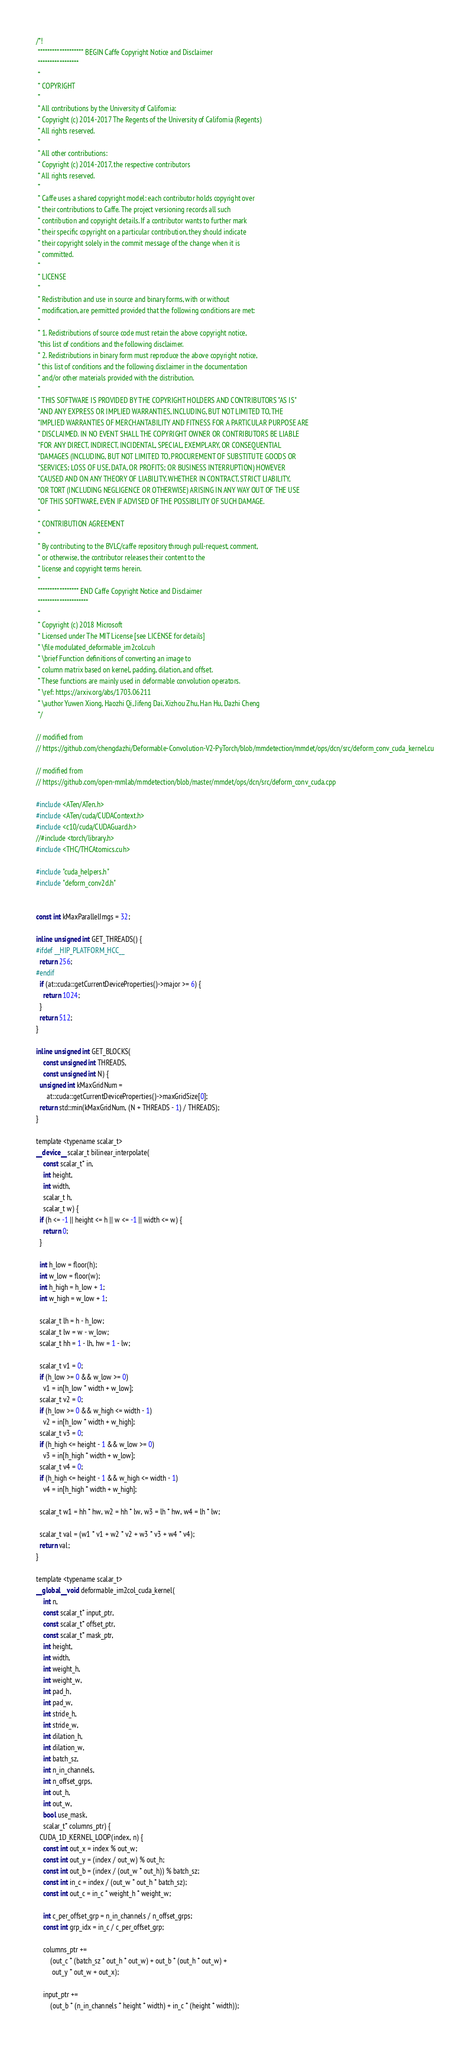<code> <loc_0><loc_0><loc_500><loc_500><_Cuda_>/*!
 ******************* BEGIN Caffe Copyright Notice and Disclaimer
 *****************
 *
 * COPYRIGHT
 *
 * All contributions by the University of California:
 * Copyright (c) 2014-2017 The Regents of the University of California (Regents)
 * All rights reserved.
 *
 * All other contributions:
 * Copyright (c) 2014-2017, the respective contributors
 * All rights reserved.
 *
 * Caffe uses a shared copyright model: each contributor holds copyright over
 * their contributions to Caffe. The project versioning records all such
 * contribution and copyright details. If a contributor wants to further mark
 * their specific copyright on a particular contribution, they should indicate
 * their copyright solely in the commit message of the change when it is
 * committed.
 *
 * LICENSE
 *
 * Redistribution and use in source and binary forms, with or without
 * modification, are permitted provided that the following conditions are met:
 *
 * 1. Redistributions of source code must retain the above copyright notice,
 *this list of conditions and the following disclaimer.
 * 2. Redistributions in binary form must reproduce the above copyright notice,
 * this list of conditions and the following disclaimer in the documentation
 * and/or other materials provided with the distribution.
 *
 * THIS SOFTWARE IS PROVIDED BY THE COPYRIGHT HOLDERS AND CONTRIBUTORS "AS IS"
 *AND ANY EXPRESS OR IMPLIED WARRANTIES, INCLUDING, BUT NOT LIMITED TO, THE
 *IMPLIED WARRANTIES OF MERCHANTABILITY AND FITNESS FOR A PARTICULAR PURPOSE ARE
 * DISCLAIMED. IN NO EVENT SHALL THE COPYRIGHT OWNER OR CONTRIBUTORS BE LIABLE
 *FOR ANY DIRECT, INDIRECT, INCIDENTAL, SPECIAL, EXEMPLARY, OR CONSEQUENTIAL
 *DAMAGES (INCLUDING, BUT NOT LIMITED TO, PROCUREMENT OF SUBSTITUTE GOODS OR
 *SERVICES; LOSS OF USE, DATA, OR PROFITS; OR BUSINESS INTERRUPTION) HOWEVER
 *CAUSED AND ON ANY THEORY OF LIABILITY, WHETHER IN CONTRACT, STRICT LIABILITY,
 *OR TORT (INCLUDING NEGLIGENCE OR OTHERWISE) ARISING IN ANY WAY OUT OF THE USE
 *OF THIS SOFTWARE, EVEN IF ADVISED OF THE POSSIBILITY OF SUCH DAMAGE.
 *
 * CONTRIBUTION AGREEMENT
 *
 * By contributing to the BVLC/caffe repository through pull-request, comment,
 * or otherwise, the contributor releases their content to the
 * license and copyright terms herein.
 *
 ***************** END Caffe Copyright Notice and Disclaimer
 *********************
 *
 * Copyright (c) 2018 Microsoft
 * Licensed under The MIT License [see LICENSE for details]
 * \file modulated_deformable_im2col.cuh
 * \brief Function definitions of converting an image to
 * column matrix based on kernel, padding, dilation, and offset.
 * These functions are mainly used in deformable convolution operators.
 * \ref: https://arxiv.org/abs/1703.06211
 * \author Yuwen Xiong, Haozhi Qi, Jifeng Dai, Xizhou Zhu, Han Hu, Dazhi Cheng
 */

// modified from
// https://github.com/chengdazhi/Deformable-Convolution-V2-PyTorch/blob/mmdetection/mmdet/ops/dcn/src/deform_conv_cuda_kernel.cu

// modified from
// https://github.com/open-mmlab/mmdetection/blob/master/mmdet/ops/dcn/src/deform_conv_cuda.cpp

#include <ATen/ATen.h>
#include <ATen/cuda/CUDAContext.h>
#include <c10/cuda/CUDAGuard.h>
//#include <torch/library.h>
#include <THC/THCAtomics.cuh>

#include "cuda_helpers.h"
#include "deform_conv2d.h"


const int kMaxParallelImgs = 32;

inline unsigned int GET_THREADS() {
#ifdef __HIP_PLATFORM_HCC__
  return 256;
#endif
  if (at::cuda::getCurrentDeviceProperties()->major >= 6) {
    return 1024;
  }
  return 512;
}

inline unsigned int GET_BLOCKS(
    const unsigned int THREADS,
    const unsigned int N) {
  unsigned int kMaxGridNum =
      at::cuda::getCurrentDeviceProperties()->maxGridSize[0];
  return std::min(kMaxGridNum, (N + THREADS - 1) / THREADS);
}

template <typename scalar_t>
__device__ scalar_t bilinear_interpolate(
    const scalar_t* in,
    int height,
    int width,
    scalar_t h,
    scalar_t w) {
  if (h <= -1 || height <= h || w <= -1 || width <= w) {
    return 0;
  }

  int h_low = floor(h);
  int w_low = floor(w);
  int h_high = h_low + 1;
  int w_high = w_low + 1;

  scalar_t lh = h - h_low;
  scalar_t lw = w - w_low;
  scalar_t hh = 1 - lh, hw = 1 - lw;

  scalar_t v1 = 0;
  if (h_low >= 0 && w_low >= 0)
    v1 = in[h_low * width + w_low];
  scalar_t v2 = 0;
  if (h_low >= 0 && w_high <= width - 1)
    v2 = in[h_low * width + w_high];
  scalar_t v3 = 0;
  if (h_high <= height - 1 && w_low >= 0)
    v3 = in[h_high * width + w_low];
  scalar_t v4 = 0;
  if (h_high <= height - 1 && w_high <= width - 1)
    v4 = in[h_high * width + w_high];

  scalar_t w1 = hh * hw, w2 = hh * lw, w3 = lh * hw, w4 = lh * lw;

  scalar_t val = (w1 * v1 + w2 * v2 + w3 * v3 + w4 * v4);
  return val;
}

template <typename scalar_t>
__global__ void deformable_im2col_cuda_kernel(
    int n,
    const scalar_t* input_ptr,
    const scalar_t* offset_ptr,
    const scalar_t* mask_ptr,
    int height,
    int width,
    int weight_h,
    int weight_w,
    int pad_h,
    int pad_w,
    int stride_h,
    int stride_w,
    int dilation_h,
    int dilation_w,
    int batch_sz,
    int n_in_channels,
    int n_offset_grps,
    int out_h,
    int out_w,
    bool use_mask,
    scalar_t* columns_ptr) {
  CUDA_1D_KERNEL_LOOP(index, n) {
    const int out_x = index % out_w;
    const int out_y = (index / out_w) % out_h;
    const int out_b = (index / (out_w * out_h)) % batch_sz;
    const int in_c = index / (out_w * out_h * batch_sz);
    const int out_c = in_c * weight_h * weight_w;

    int c_per_offset_grp = n_in_channels / n_offset_grps;
    const int grp_idx = in_c / c_per_offset_grp;

    columns_ptr +=
        (out_c * (batch_sz * out_h * out_w) + out_b * (out_h * out_w) +
         out_y * out_w + out_x);

    input_ptr +=
        (out_b * (n_in_channels * height * width) + in_c * (height * width));
</code> 